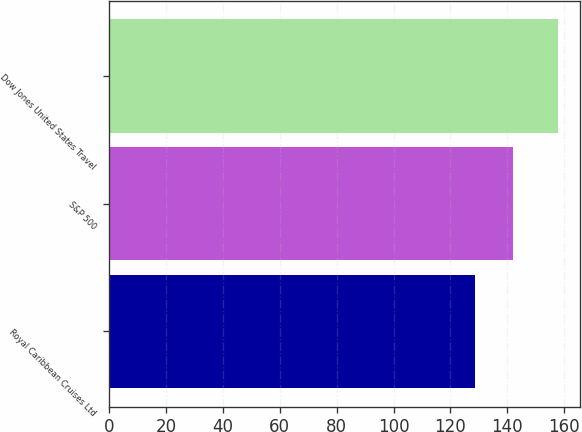<chart> <loc_0><loc_0><loc_500><loc_500><bar_chart><fcel>Royal Caribbean Cruises Ltd<fcel>S&P 500<fcel>Dow Jones United States Travel<nl><fcel>128.7<fcel>142.1<fcel>157.71<nl></chart> 